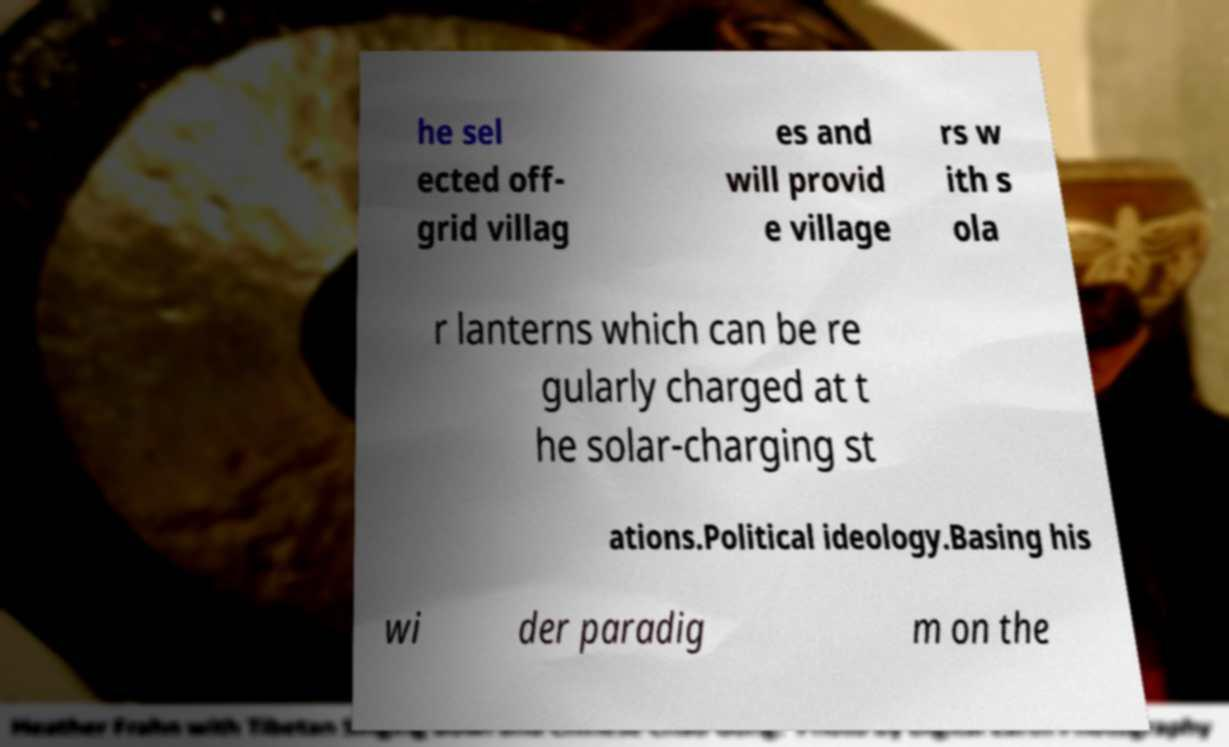Can you read and provide the text displayed in the image?This photo seems to have some interesting text. Can you extract and type it out for me? he sel ected off- grid villag es and will provid e village rs w ith s ola r lanterns which can be re gularly charged at t he solar-charging st ations.Political ideology.Basing his wi der paradig m on the 